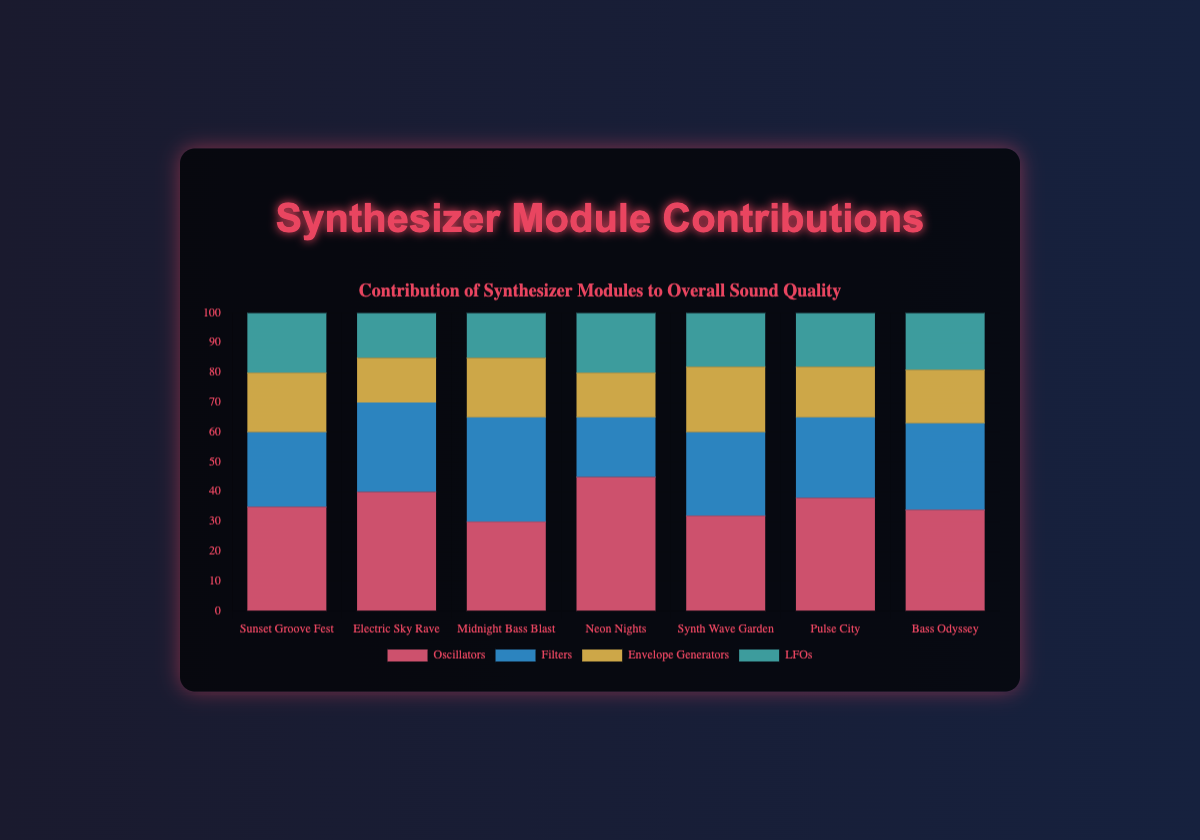What is the total contribution score of synthesizer modules for "Synth Wave Garden"? To find the total contribution score, sum up the contributions of all modules for "Synth Wave Garden" (32 + 28 + 22 + 18).
Answer: 100 Which performance had the highest contribution score from Oscillators? By examining the height of the red sections in the stacked bars, "Neon Nights" has the highest contribution from Oscillators at 45.
Answer: Neon Nights Which performance has the lowest overall contribution from Envelope Generators and LFOs combined? Summing up Envelope Generators and LFOs for each performance shows that "Electric Sky Rave" has the lowest combined contribution (15 + 15 = 30).
Answer: Electric Sky Rave Which module had the highest average contribution across all performances? Calculate the average for each module: 
- Oscillators: (35 + 40 + 30 + 45 + 32 + 38 + 34)/7 = 36.29
- Filters: (25 + 30 + 35 + 20 + 28 + 27 + 29)/7 = 27.71
- Envelope Generators: (20 + 15 + 20 + 15 + 22 + 17 + 18)/7 = 18.14
- LFOs: (20 + 15 + 15 + 20 + 18 + 18 + 19)/7 = 17.86
Oscillators have the highest average contribution at approximately 36.29.
Answer: Oscillators During which performance was the contribution from Filters equal to the contribution from Oscillators and LFOs combined? Create a condition where Filters' contribution equals Oscillators plus LFOs:
- "Sunset Groove Fest": 25 ≠ 35 + 20 (55)
- "Electric Sky Rave": 30 ≠ 40 + 15 (55)
- "Midnight Bass Blast": 35 = 30 + 15 (45)
- "Neon Nights": 20 ≠ 45 + 20 (65)
- "Synth Wave Garden": 28 ≠ 32 + 18 (50)
- "Pulse City": 27 ≠ 38 + 18 (56)
- "Bass Odyssey": 29 ≠ 34 + 19 (53)
"Midnight Bass Blast" meets the condition.
Answer: Midnight Bass Blast Which performance had the smallest difference between the highest and lowest contributing modules? Calculate the differences:
- "Sunset Groove Fest": 35 - 20 = 15
- "Electric Sky Rave": 40 - 15 = 25
- "Midnight Bass Blast": 35 - 15 = 20
- "Neon Nights": 45 - 15 = 30
- "Synth Wave Garden": 32 - 18 = 14
- "Pulse City": 38 - 17 = 21
- "Bass Odyssey": 34 - 18 = 16
"Synth Wave Garden" has the smallest difference at 14.
Answer: Synth Wave Garden Between "Pulse City" and "Neon Nights", which performance had a higher total contribution from Filters and LFOs combined? Calculate the combined contributions:
- "Pulse City": 27 + 18 = 45
- "Neon Nights": 20 + 20 = 40
"Pulse City" has a higher combined contribution.
Answer: Pulse City 